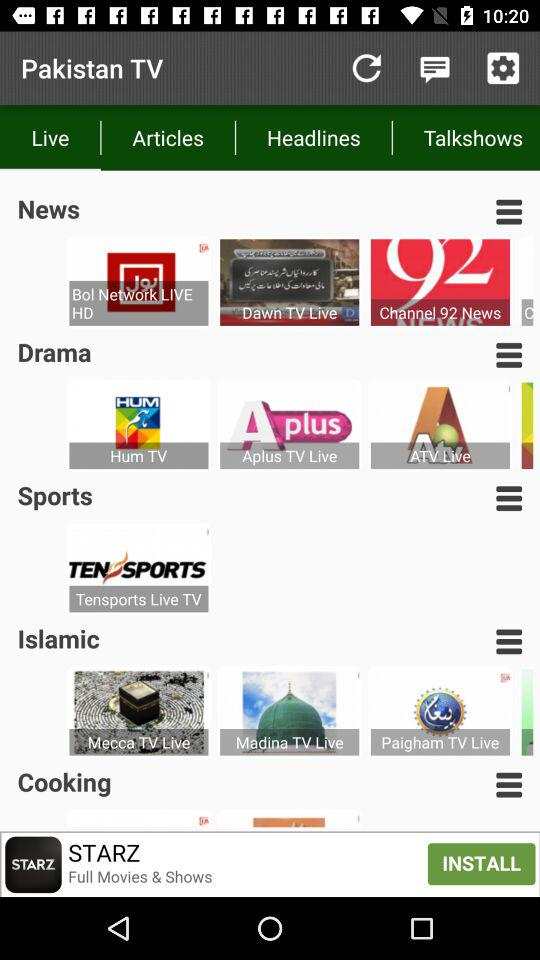What is the name of the application? The name of the application is "Pakistan TV". 